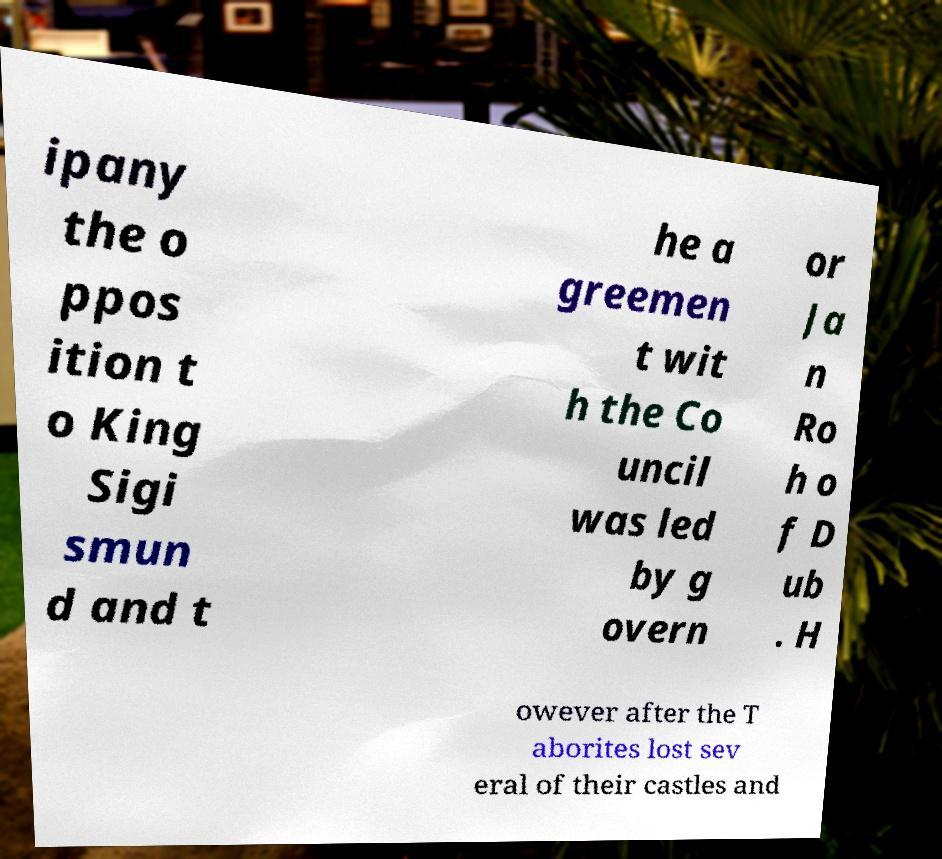For documentation purposes, I need the text within this image transcribed. Could you provide that? ipany the o ppos ition t o King Sigi smun d and t he a greemen t wit h the Co uncil was led by g overn or Ja n Ro h o f D ub . H owever after the T aborites lost sev eral of their castles and 